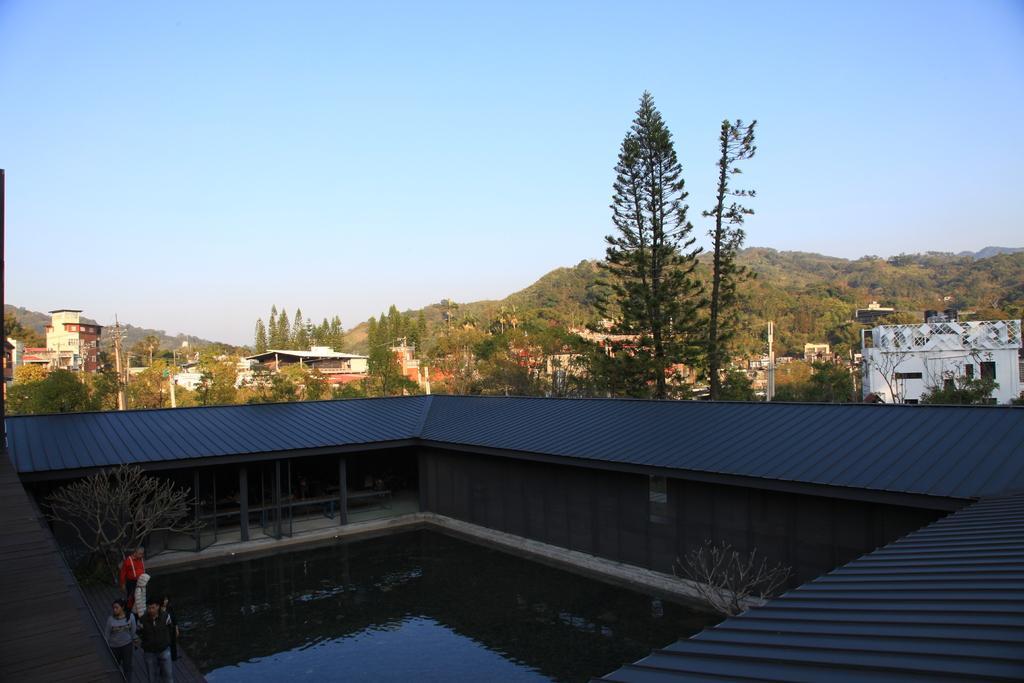Please provide a concise description of this image. In this picture I can see water, there are group of people standing, there are trees, houses, poles, hills, and in the background there is sky. 